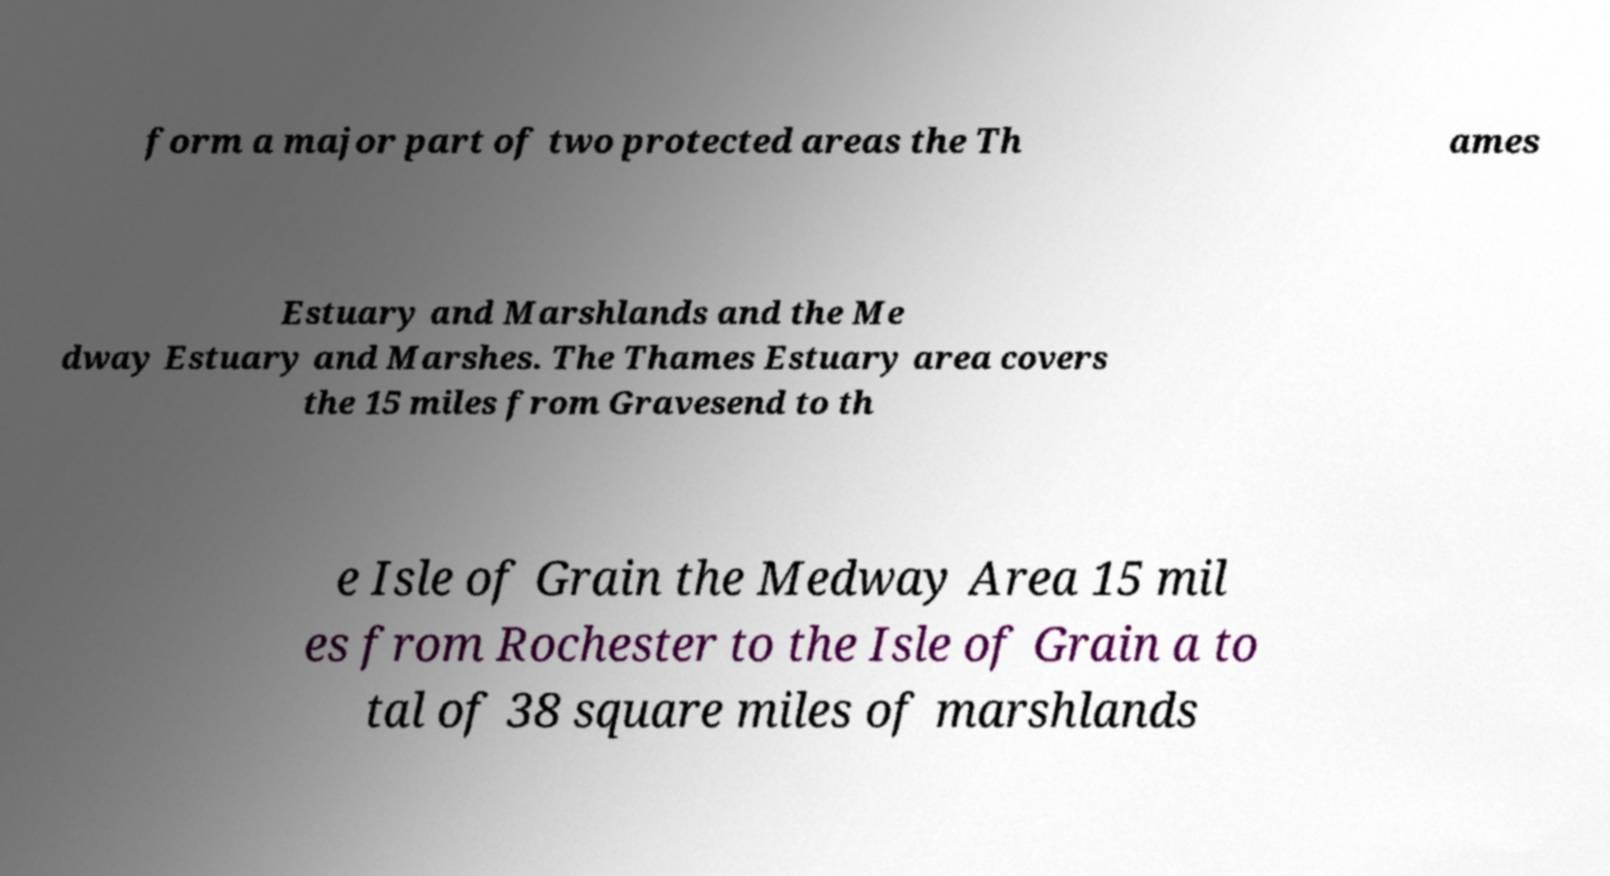There's text embedded in this image that I need extracted. Can you transcribe it verbatim? form a major part of two protected areas the Th ames Estuary and Marshlands and the Me dway Estuary and Marshes. The Thames Estuary area covers the 15 miles from Gravesend to th e Isle of Grain the Medway Area 15 mil es from Rochester to the Isle of Grain a to tal of 38 square miles of marshlands 